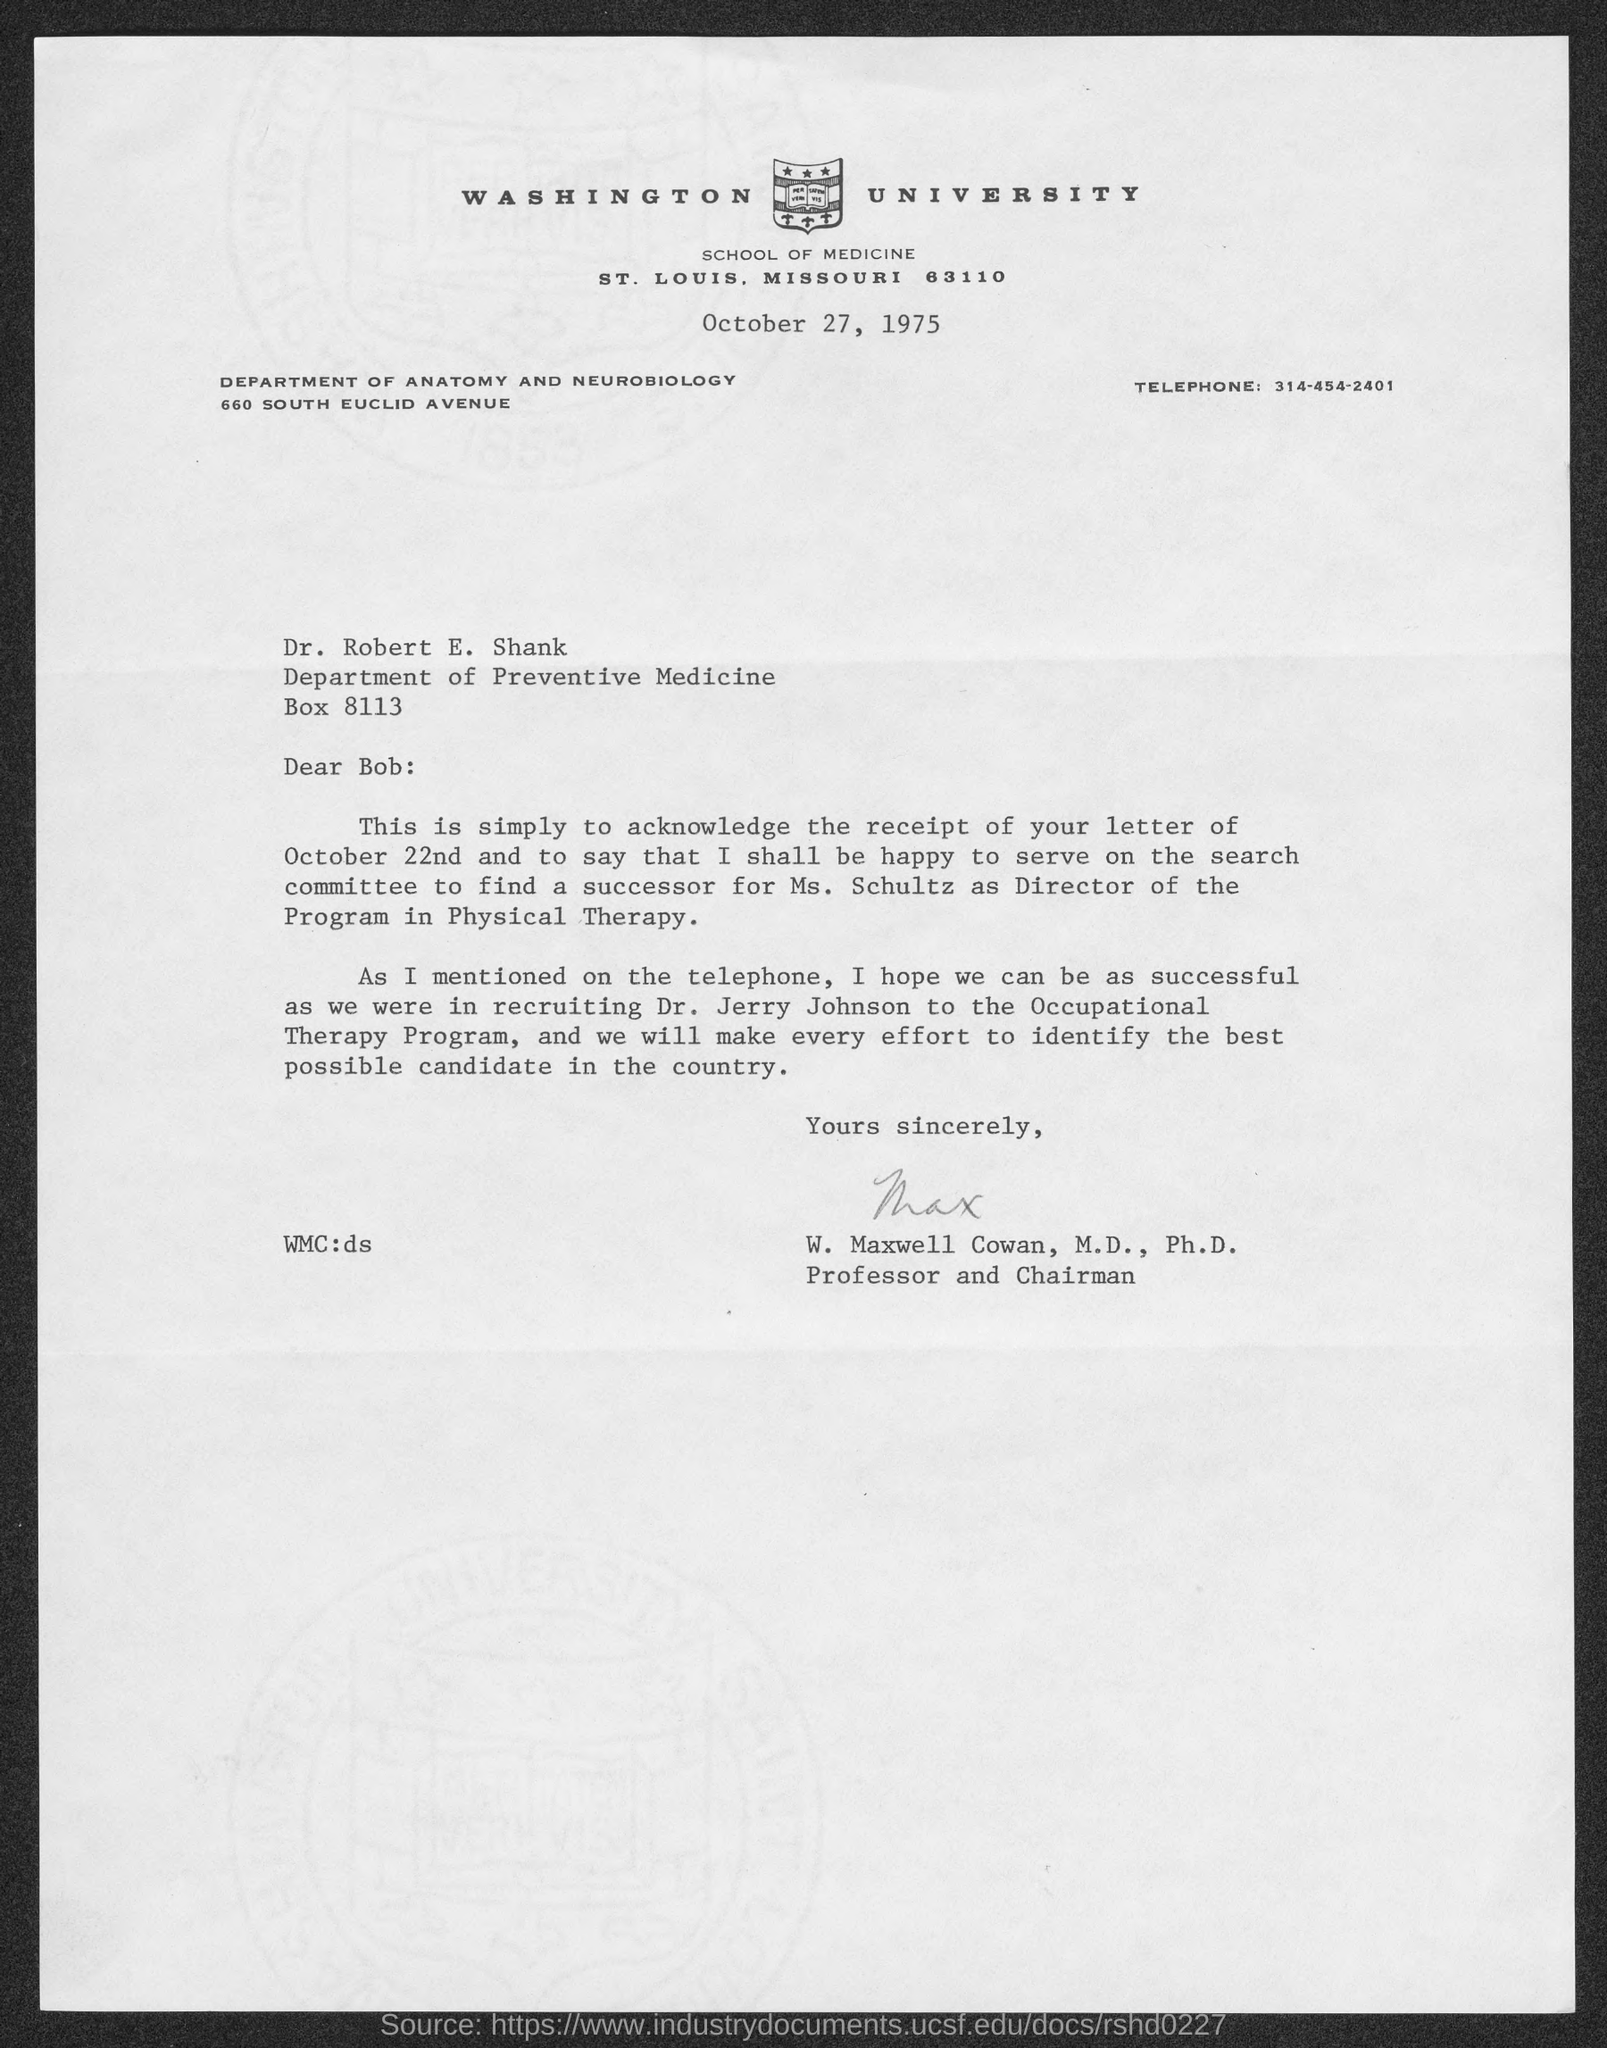Highlight a few significant elements in this photo. The sender of the letter is W. Maxwell Cowan. Dr. Robert works in the Department of Preventive Medicine. The person whom Ms. Schultz's successor needs to be found is unknown. 